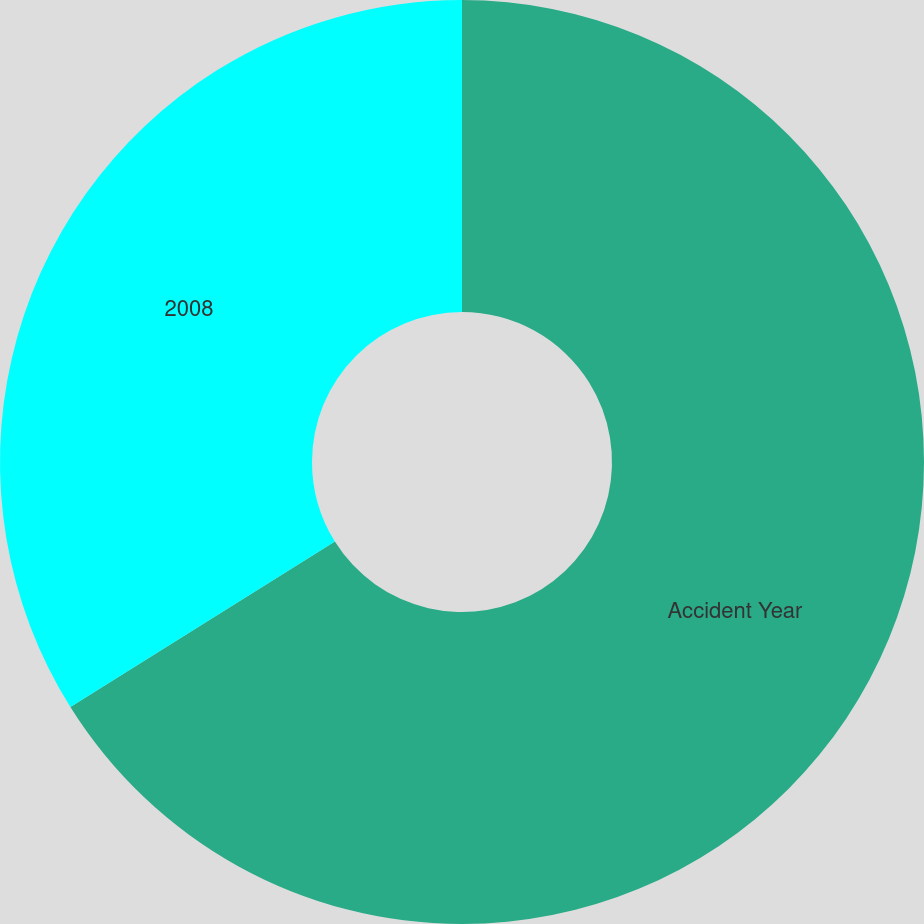Convert chart to OTSL. <chart><loc_0><loc_0><loc_500><loc_500><pie_chart><fcel>Accident Year<fcel>2008<nl><fcel>66.1%<fcel>33.9%<nl></chart> 